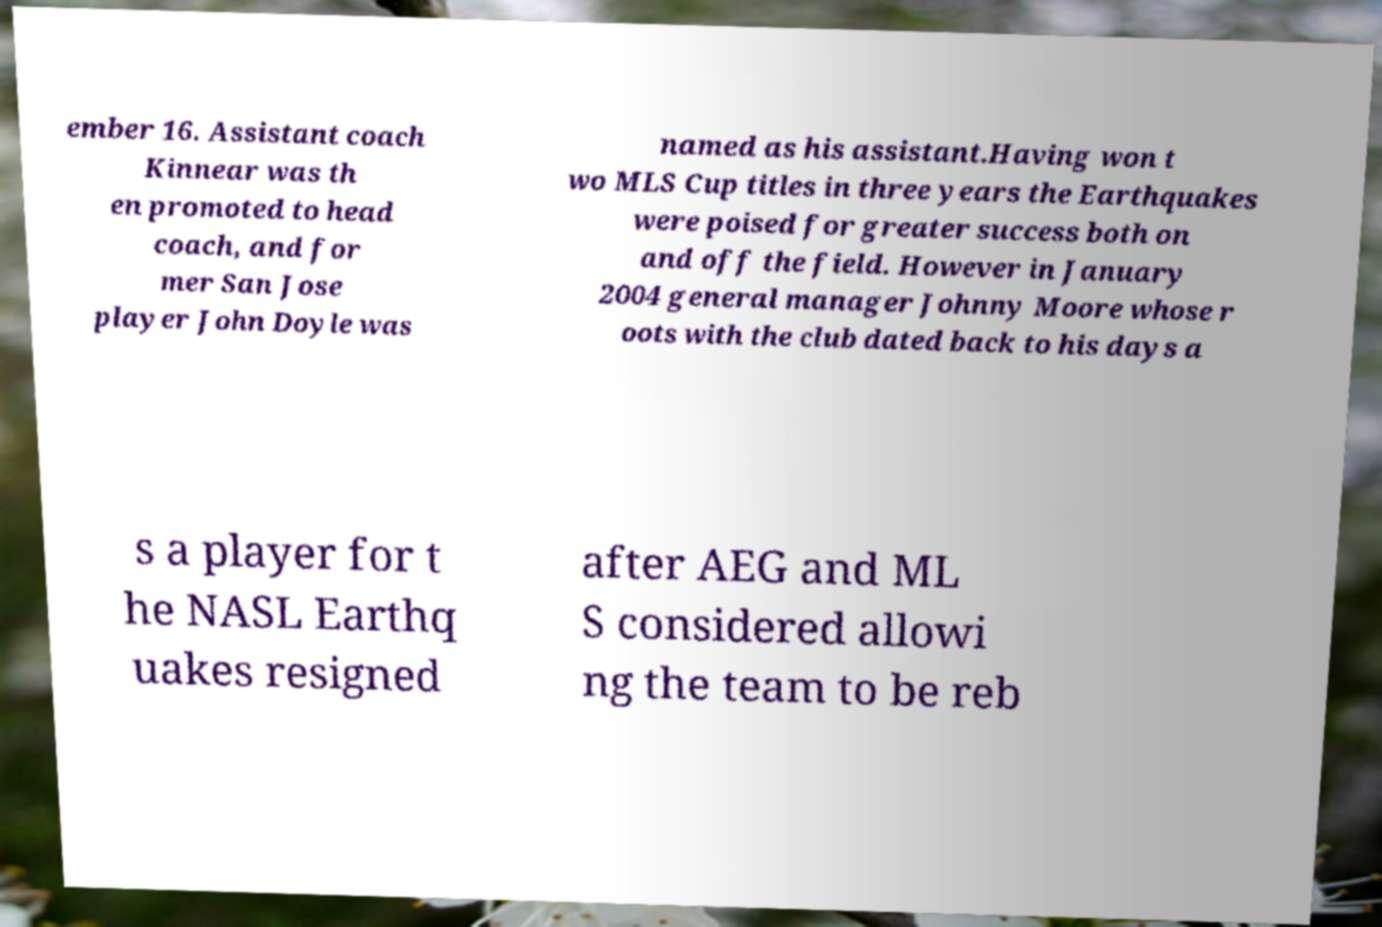What messages or text are displayed in this image? I need them in a readable, typed format. ember 16. Assistant coach Kinnear was th en promoted to head coach, and for mer San Jose player John Doyle was named as his assistant.Having won t wo MLS Cup titles in three years the Earthquakes were poised for greater success both on and off the field. However in January 2004 general manager Johnny Moore whose r oots with the club dated back to his days a s a player for t he NASL Earthq uakes resigned after AEG and ML S considered allowi ng the team to be reb 